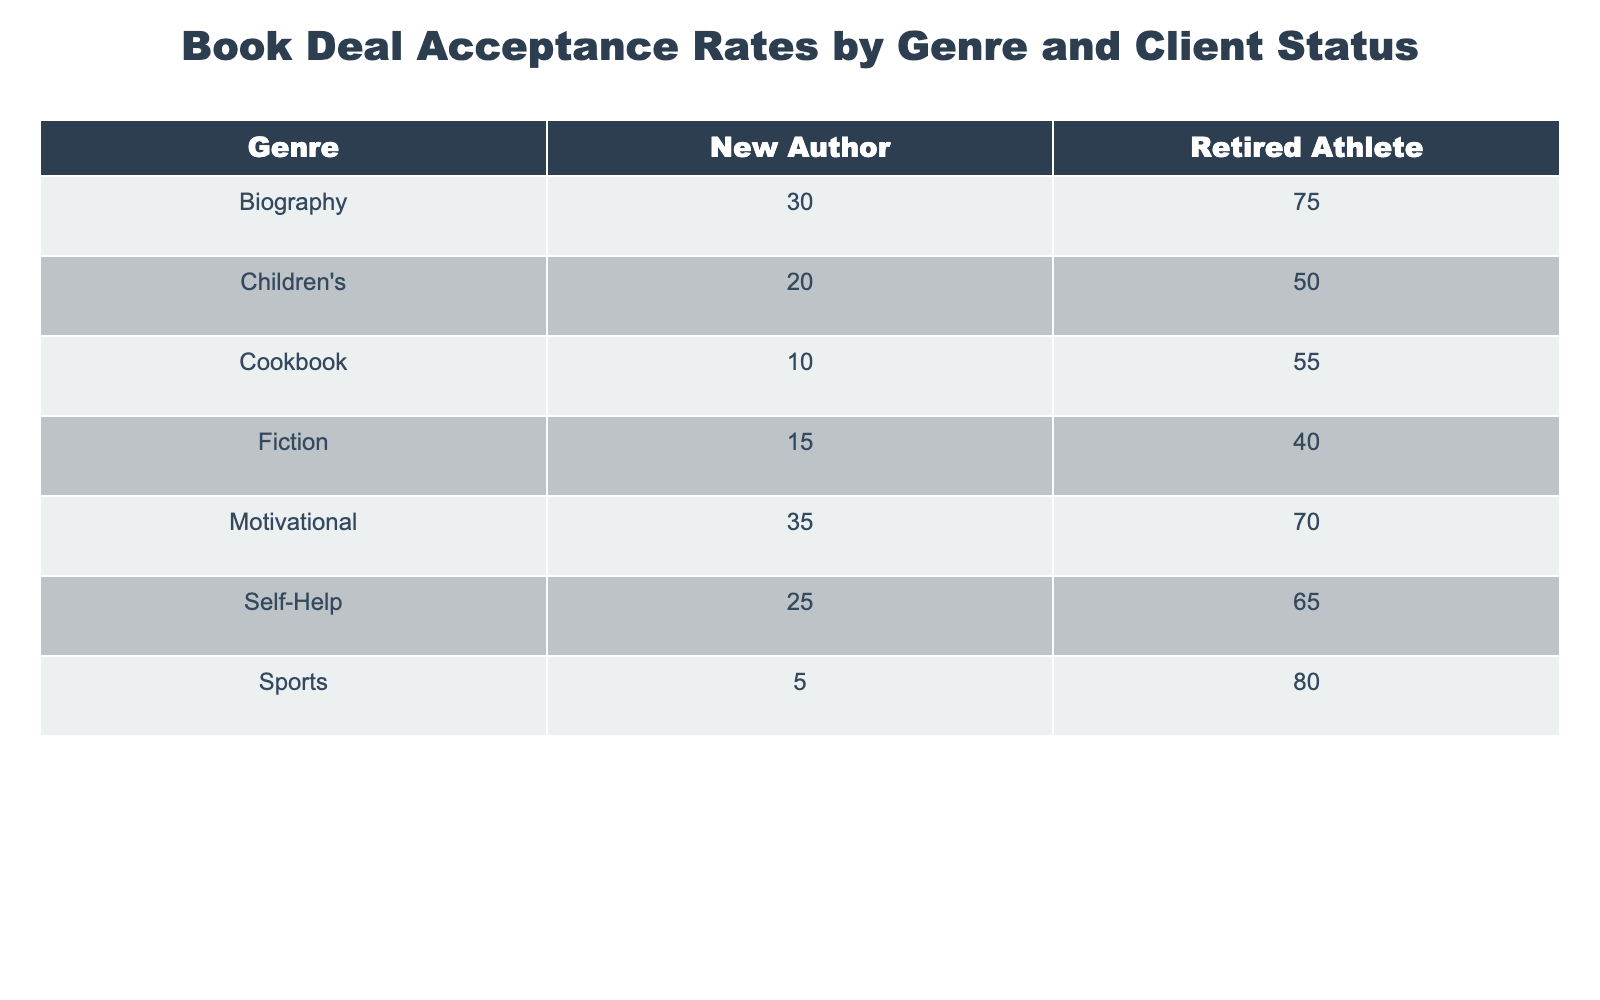What's the highest acceptance rate for a retired athlete? The table shows the acceptance rates for various genres by client status. Looking down the column for 'Retired Athlete', the highest acceptance rate is 80 for the genre 'Sports'.
Answer: 80 What's the acceptance rate for New Authors in the Self-Help genre? According to the table under the 'New Author' category for the 'Self-Help' genre, the acceptance rate is 25.
Answer: 25 Is the acceptance rate higher for Retired Athletes in Cookbooks or in Children's books? For Retired Athletes, the acceptance rate for Cookbooks is 55, while for Children's books it is 50. Since 55 is greater than 50, the acceptance rate is higher for Cookbooks.
Answer: Yes What is the average acceptance rate for all genres for Retired Athletes? To find the average, we sum the acceptance rates for Retired Athletes: 75 (Biography) + 65 (Self-Help) + 40 (Fiction) + 50 (Children's) + 55 (Cookbook) + 70 (Motivational) + 80 (Sports) = 435. There are 7 genres, so the average is 435/7 = 62.14.
Answer: 62.14 Do New Authors have an acceptance rate higher than Retired Athletes in any genre? We need to compare the acceptance rates for each genre between New Authors and Retired Athletes. After checking each genre, New Authors have a maximum acceptance rate of 35 in 'Motivational', while Retired Athletes have 70. Since no New Authors rate exceeds that of Retired Athletes, the answer is no.
Answer: No What is the difference in acceptance rates for New Authors between the Fiction and Motivational genres? For New Authors, the acceptance rate for Fiction is 15, and for Motivational, it is 35. To find the difference, we calculate 35 - 15 = 20.
Answer: 20 For which genre do retired athletes have the lowest acceptance rate? In the column for Retired Athletes, the lowest acceptance rate is found in the 'Fiction' genre, which is 40.
Answer: 40 How many genres have an acceptance rate of 30 or higher for New Authors? We can refer to the 'New Author' acceptance rates: Biography (30), Self-Help (25), Fiction (15), Children's (20), Cookbook (10), Motivational (35), and Sports (5). Only 'Biography' and 'Motivational' have rates of 30 or higher, totaling 2 genres.
Answer: 2 